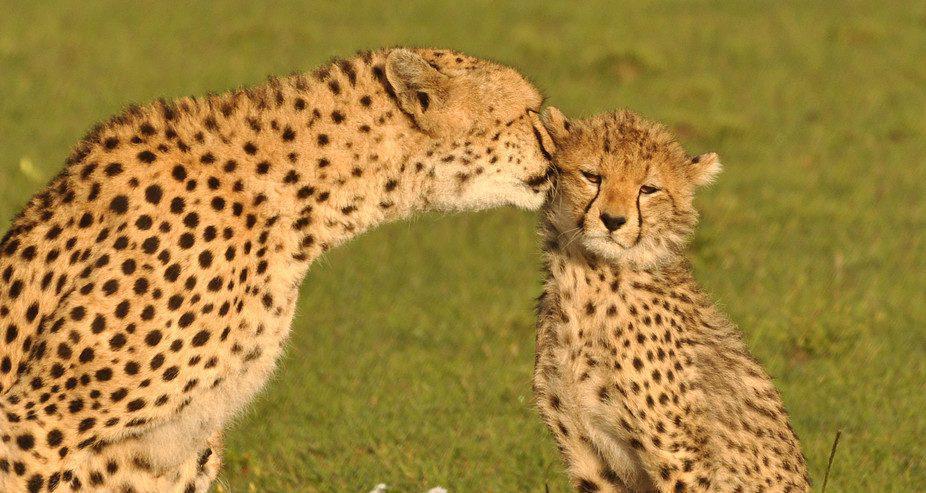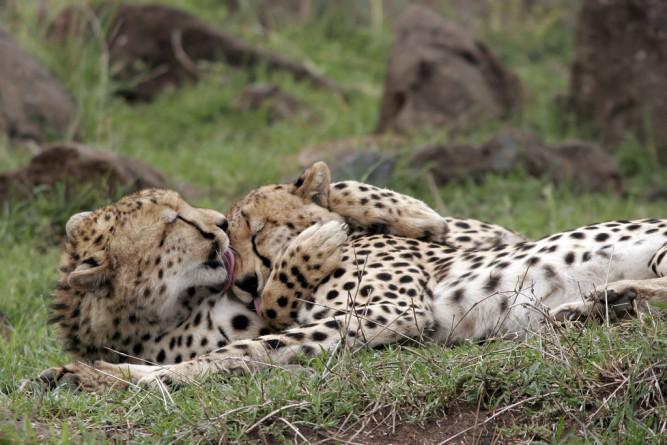The first image is the image on the left, the second image is the image on the right. For the images shown, is this caption "The right image has at least two cheetahs." true? Answer yes or no. Yes. The first image is the image on the left, the second image is the image on the right. Given the left and right images, does the statement "A larger spotted wild cat is extending its neck and head toward the head of a smaller spotted wild cat." hold true? Answer yes or no. Yes. 